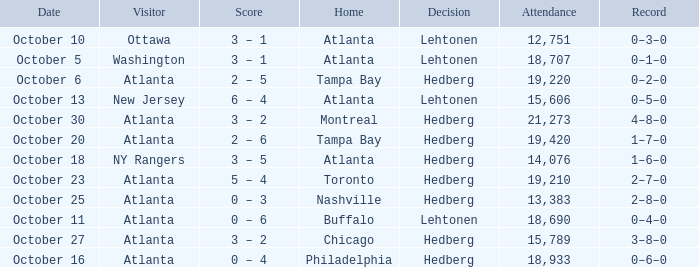What was the record on the game that was played on october 27? 3–8–0. 